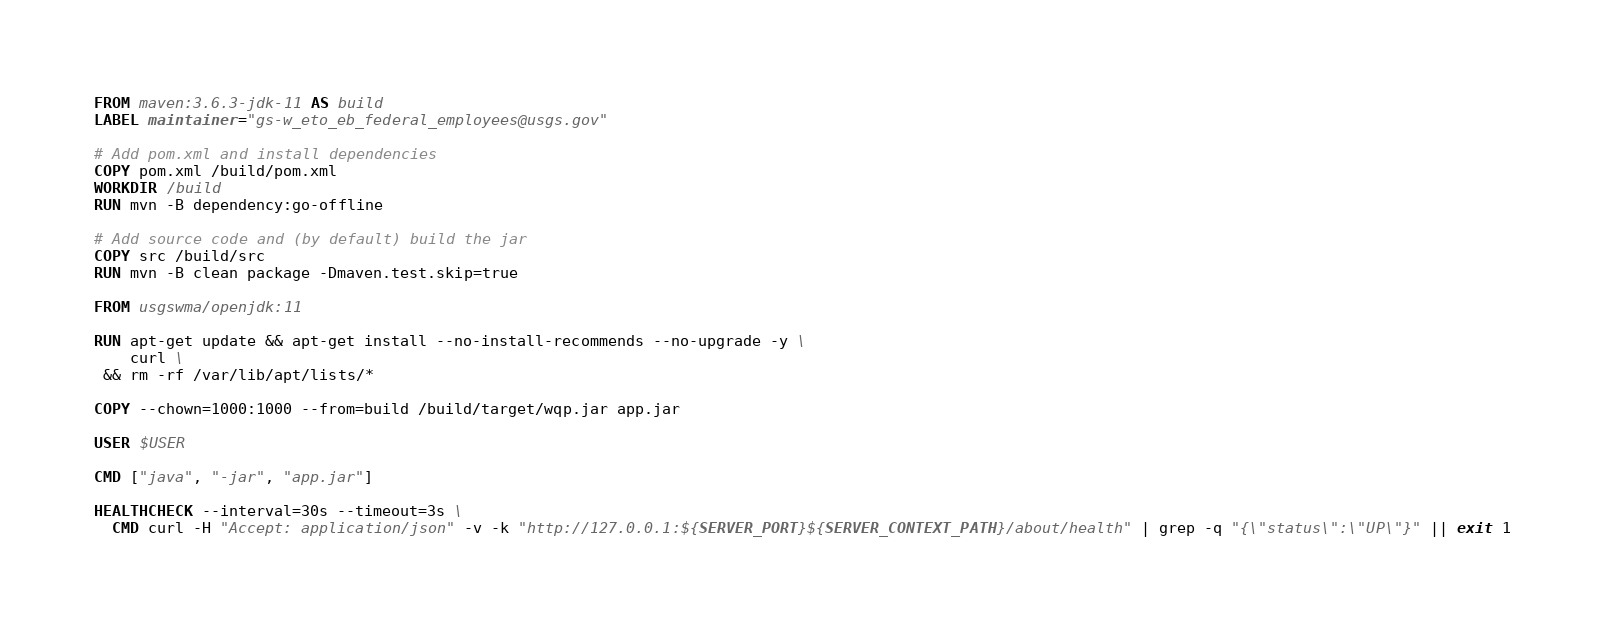Convert code to text. <code><loc_0><loc_0><loc_500><loc_500><_Dockerfile_>FROM maven:3.6.3-jdk-11 AS build
LABEL maintainer="gs-w_eto_eb_federal_employees@usgs.gov"

# Add pom.xml and install dependencies
COPY pom.xml /build/pom.xml
WORKDIR /build
RUN mvn -B dependency:go-offline

# Add source code and (by default) build the jar
COPY src /build/src
RUN mvn -B clean package -Dmaven.test.skip=true

FROM usgswma/openjdk:11

RUN apt-get update && apt-get install --no-install-recommends --no-upgrade -y \
    curl \
 && rm -rf /var/lib/apt/lists/*

COPY --chown=1000:1000 --from=build /build/target/wqp.jar app.jar

USER $USER

CMD ["java", "-jar", "app.jar"]

HEALTHCHECK --interval=30s --timeout=3s \
  CMD curl -H "Accept: application/json" -v -k "http://127.0.0.1:${SERVER_PORT}${SERVER_CONTEXT_PATH}/about/health" | grep -q "{\"status\":\"UP\"}" || exit 1
</code> 